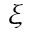<formula> <loc_0><loc_0><loc_500><loc_500>\xi</formula> 